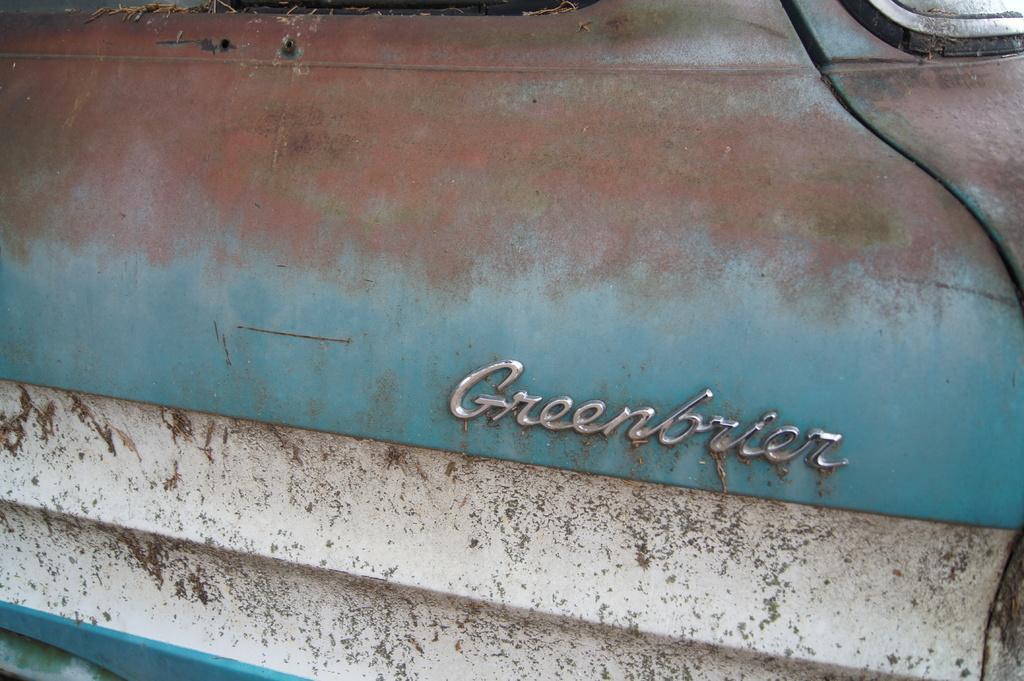Can you describe this image briefly? In this picture I can see a logo on the vehicle. 